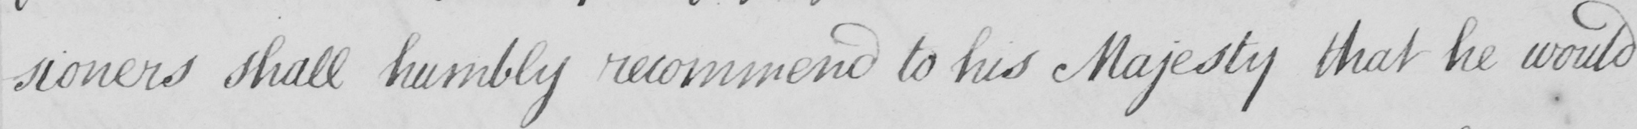Please transcribe the handwritten text in this image. -sioners shall humbly recommend to his Majesty that he would 